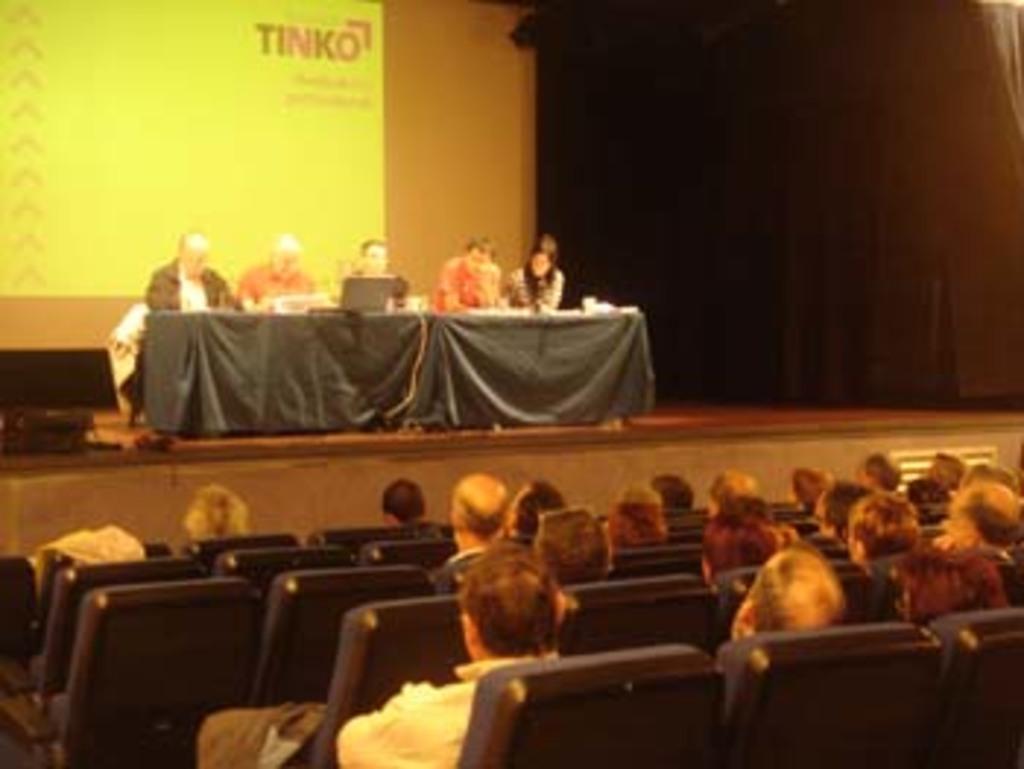Please provide a concise description of this image. In this image in front there are people sitting on the chairs. At the center of the image there are people sitting on the chairs. In front of them there is a table. On top of it there is a laptop and a few other objects. Behind them there is a screen. On the right side of the image there is a curtain. 